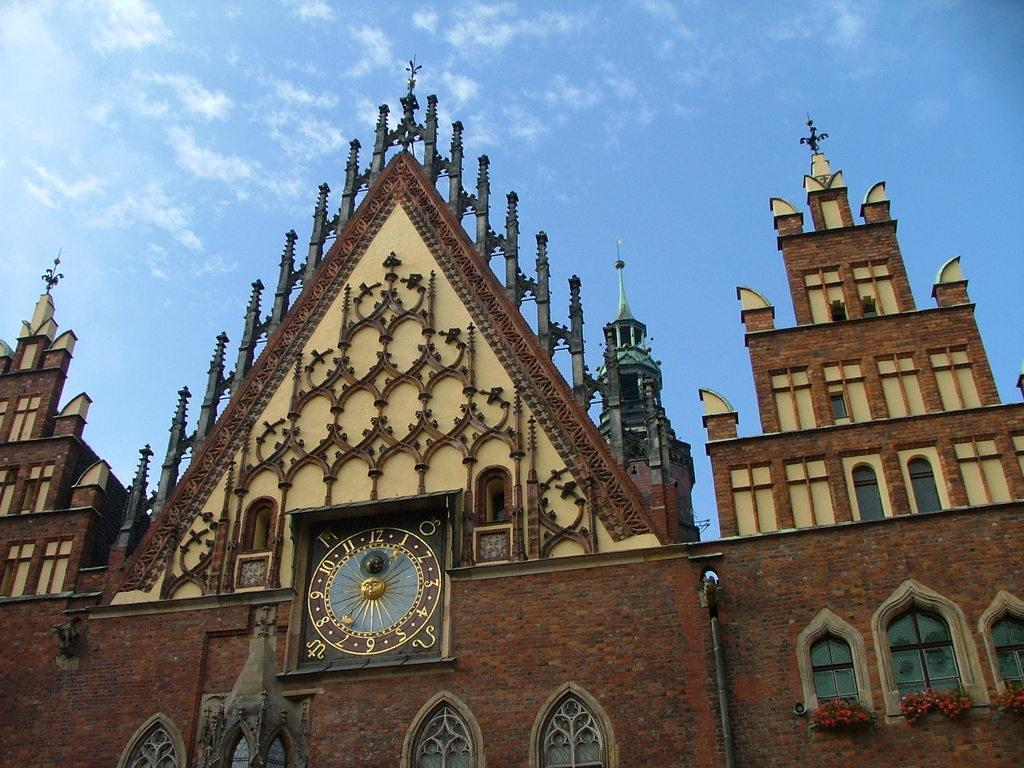What type of structure is in the image? There is a building in the image. What colors are used for the building? The building is in cream and brown color. Are there any specific features on the building? Yes, there are windows and a clock on the building. What can be seen in the background of the image? There are clouds and the sky visible in the background of the image. What type of potato is being used to create the clock on the building? There is no potato present in the image, and the clock is not made of any potato. Can you describe the creature that is climbing the building in the image? There is no creature climbing the building in the image; it only features a building with windows and a clock. 